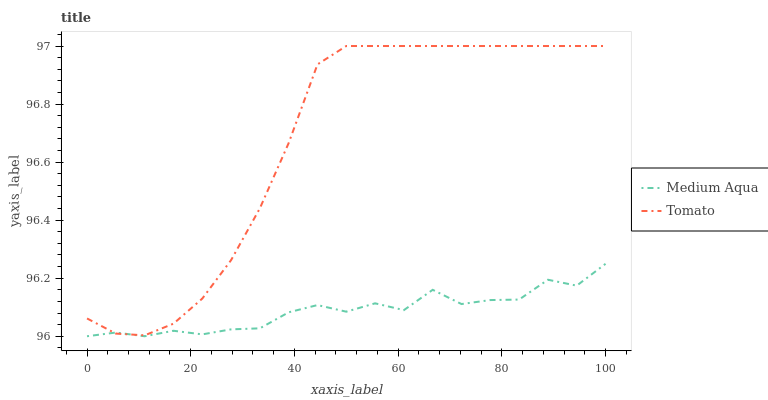Does Medium Aqua have the minimum area under the curve?
Answer yes or no. Yes. Does Tomato have the maximum area under the curve?
Answer yes or no. Yes. Does Medium Aqua have the maximum area under the curve?
Answer yes or no. No. Is Tomato the smoothest?
Answer yes or no. Yes. Is Medium Aqua the roughest?
Answer yes or no. Yes. Is Medium Aqua the smoothest?
Answer yes or no. No. Does Medium Aqua have the lowest value?
Answer yes or no. Yes. Does Tomato have the highest value?
Answer yes or no. Yes. Does Medium Aqua have the highest value?
Answer yes or no. No. Does Tomato intersect Medium Aqua?
Answer yes or no. Yes. Is Tomato less than Medium Aqua?
Answer yes or no. No. Is Tomato greater than Medium Aqua?
Answer yes or no. No. 